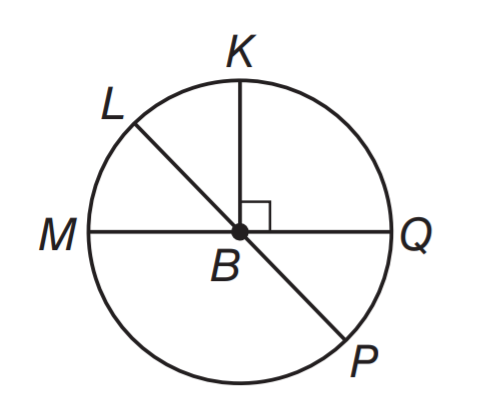Answer the mathemtical geometry problem and directly provide the correct option letter.
Question: In \odot B, m \angle L B M = 3 x and m \angle L B Q = 4 x + 61. What is the measure of \angle P B Q?
Choices: A: 17 B: 34 C: 51 D: 61 C 